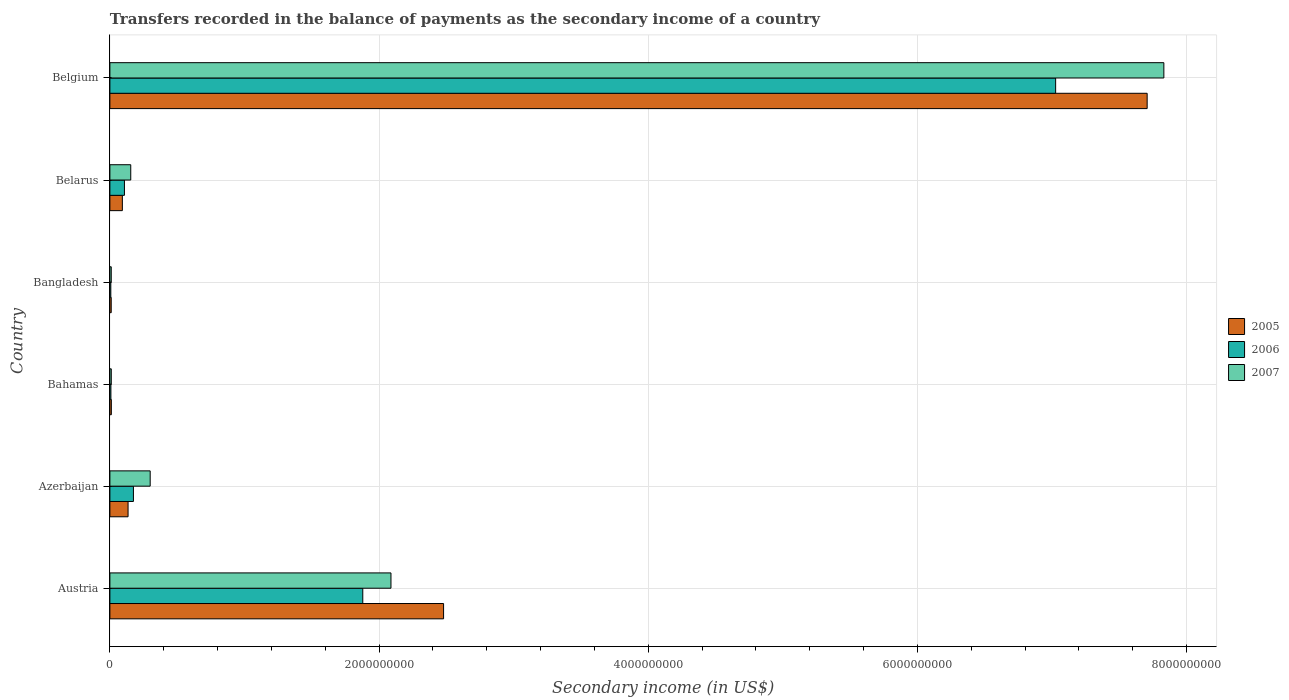How many different coloured bars are there?
Ensure brevity in your answer.  3. How many groups of bars are there?
Provide a succinct answer. 6. Are the number of bars per tick equal to the number of legend labels?
Your answer should be compact. Yes. Are the number of bars on each tick of the Y-axis equal?
Keep it short and to the point. Yes. How many bars are there on the 2nd tick from the top?
Ensure brevity in your answer.  3. How many bars are there on the 2nd tick from the bottom?
Your answer should be compact. 3. What is the label of the 3rd group of bars from the top?
Your answer should be very brief. Bangladesh. In how many cases, is the number of bars for a given country not equal to the number of legend labels?
Your answer should be very brief. 0. What is the secondary income of in 2007 in Bangladesh?
Keep it short and to the point. 1.01e+07. Across all countries, what is the maximum secondary income of in 2005?
Your answer should be very brief. 7.71e+09. Across all countries, what is the minimum secondary income of in 2007?
Your answer should be very brief. 1.01e+07. In which country was the secondary income of in 2005 minimum?
Give a very brief answer. Bangladesh. What is the total secondary income of in 2005 in the graph?
Your answer should be very brief. 1.04e+1. What is the difference between the secondary income of in 2006 in Austria and that in Belgium?
Make the answer very short. -5.15e+09. What is the difference between the secondary income of in 2006 in Bahamas and the secondary income of in 2005 in Azerbaijan?
Provide a short and direct response. -1.28e+08. What is the average secondary income of in 2005 per country?
Give a very brief answer. 1.74e+09. What is the difference between the secondary income of in 2005 and secondary income of in 2007 in Bangladesh?
Your answer should be very brief. -1.71e+05. What is the ratio of the secondary income of in 2007 in Austria to that in Azerbaijan?
Provide a succinct answer. 6.97. Is the secondary income of in 2005 in Azerbaijan less than that in Belarus?
Your answer should be very brief. No. What is the difference between the highest and the second highest secondary income of in 2006?
Offer a very short reply. 5.15e+09. What is the difference between the highest and the lowest secondary income of in 2007?
Your answer should be very brief. 7.82e+09. Is the sum of the secondary income of in 2007 in Azerbaijan and Bangladesh greater than the maximum secondary income of in 2006 across all countries?
Give a very brief answer. No. What does the 2nd bar from the bottom in Bahamas represents?
Offer a very short reply. 2006. Is it the case that in every country, the sum of the secondary income of in 2007 and secondary income of in 2005 is greater than the secondary income of in 2006?
Your answer should be compact. Yes. Are all the bars in the graph horizontal?
Ensure brevity in your answer.  Yes. What is the difference between two consecutive major ticks on the X-axis?
Offer a very short reply. 2.00e+09. Are the values on the major ticks of X-axis written in scientific E-notation?
Your response must be concise. No. Does the graph contain any zero values?
Offer a terse response. No. Does the graph contain grids?
Offer a terse response. Yes. Where does the legend appear in the graph?
Keep it short and to the point. Center right. How are the legend labels stacked?
Keep it short and to the point. Vertical. What is the title of the graph?
Your answer should be compact. Transfers recorded in the balance of payments as the secondary income of a country. What is the label or title of the X-axis?
Ensure brevity in your answer.  Secondary income (in US$). What is the label or title of the Y-axis?
Offer a terse response. Country. What is the Secondary income (in US$) of 2005 in Austria?
Offer a very short reply. 2.48e+09. What is the Secondary income (in US$) of 2006 in Austria?
Provide a succinct answer. 1.88e+09. What is the Secondary income (in US$) in 2007 in Austria?
Your response must be concise. 2.09e+09. What is the Secondary income (in US$) in 2005 in Azerbaijan?
Offer a very short reply. 1.35e+08. What is the Secondary income (in US$) of 2006 in Azerbaijan?
Provide a succinct answer. 1.75e+08. What is the Secondary income (in US$) in 2007 in Azerbaijan?
Give a very brief answer. 2.99e+08. What is the Secondary income (in US$) of 2005 in Bahamas?
Your answer should be compact. 1.08e+07. What is the Secondary income (in US$) of 2006 in Bahamas?
Give a very brief answer. 7.49e+06. What is the Secondary income (in US$) in 2007 in Bahamas?
Give a very brief answer. 1.03e+07. What is the Secondary income (in US$) in 2005 in Bangladesh?
Offer a very short reply. 9.91e+06. What is the Secondary income (in US$) in 2006 in Bangladesh?
Your answer should be compact. 6.82e+06. What is the Secondary income (in US$) in 2007 in Bangladesh?
Provide a short and direct response. 1.01e+07. What is the Secondary income (in US$) in 2005 in Belarus?
Give a very brief answer. 9.27e+07. What is the Secondary income (in US$) of 2006 in Belarus?
Provide a succinct answer. 1.08e+08. What is the Secondary income (in US$) in 2007 in Belarus?
Give a very brief answer. 1.55e+08. What is the Secondary income (in US$) in 2005 in Belgium?
Provide a succinct answer. 7.71e+09. What is the Secondary income (in US$) in 2006 in Belgium?
Ensure brevity in your answer.  7.03e+09. What is the Secondary income (in US$) in 2007 in Belgium?
Give a very brief answer. 7.83e+09. Across all countries, what is the maximum Secondary income (in US$) in 2005?
Give a very brief answer. 7.71e+09. Across all countries, what is the maximum Secondary income (in US$) of 2006?
Keep it short and to the point. 7.03e+09. Across all countries, what is the maximum Secondary income (in US$) of 2007?
Offer a very short reply. 7.83e+09. Across all countries, what is the minimum Secondary income (in US$) in 2005?
Offer a very short reply. 9.91e+06. Across all countries, what is the minimum Secondary income (in US$) of 2006?
Your response must be concise. 6.82e+06. Across all countries, what is the minimum Secondary income (in US$) in 2007?
Keep it short and to the point. 1.01e+07. What is the total Secondary income (in US$) of 2005 in the graph?
Your answer should be compact. 1.04e+1. What is the total Secondary income (in US$) in 2006 in the graph?
Your response must be concise. 9.20e+09. What is the total Secondary income (in US$) of 2007 in the graph?
Your answer should be very brief. 1.04e+1. What is the difference between the Secondary income (in US$) in 2005 in Austria and that in Azerbaijan?
Provide a short and direct response. 2.34e+09. What is the difference between the Secondary income (in US$) of 2006 in Austria and that in Azerbaijan?
Give a very brief answer. 1.70e+09. What is the difference between the Secondary income (in US$) in 2007 in Austria and that in Azerbaijan?
Give a very brief answer. 1.79e+09. What is the difference between the Secondary income (in US$) in 2005 in Austria and that in Bahamas?
Your answer should be very brief. 2.47e+09. What is the difference between the Secondary income (in US$) in 2006 in Austria and that in Bahamas?
Offer a terse response. 1.87e+09. What is the difference between the Secondary income (in US$) in 2007 in Austria and that in Bahamas?
Ensure brevity in your answer.  2.08e+09. What is the difference between the Secondary income (in US$) of 2005 in Austria and that in Bangladesh?
Offer a very short reply. 2.47e+09. What is the difference between the Secondary income (in US$) of 2006 in Austria and that in Bangladesh?
Offer a terse response. 1.87e+09. What is the difference between the Secondary income (in US$) in 2007 in Austria and that in Bangladesh?
Give a very brief answer. 2.08e+09. What is the difference between the Secondary income (in US$) of 2005 in Austria and that in Belarus?
Give a very brief answer. 2.39e+09. What is the difference between the Secondary income (in US$) in 2006 in Austria and that in Belarus?
Your answer should be compact. 1.77e+09. What is the difference between the Secondary income (in US$) of 2007 in Austria and that in Belarus?
Offer a very short reply. 1.93e+09. What is the difference between the Secondary income (in US$) in 2005 in Austria and that in Belgium?
Give a very brief answer. -5.23e+09. What is the difference between the Secondary income (in US$) in 2006 in Austria and that in Belgium?
Your answer should be compact. -5.15e+09. What is the difference between the Secondary income (in US$) of 2007 in Austria and that in Belgium?
Provide a succinct answer. -5.74e+09. What is the difference between the Secondary income (in US$) of 2005 in Azerbaijan and that in Bahamas?
Give a very brief answer. 1.24e+08. What is the difference between the Secondary income (in US$) in 2006 in Azerbaijan and that in Bahamas?
Make the answer very short. 1.67e+08. What is the difference between the Secondary income (in US$) in 2007 in Azerbaijan and that in Bahamas?
Your answer should be compact. 2.89e+08. What is the difference between the Secondary income (in US$) of 2005 in Azerbaijan and that in Bangladesh?
Offer a terse response. 1.25e+08. What is the difference between the Secondary income (in US$) in 2006 in Azerbaijan and that in Bangladesh?
Provide a short and direct response. 1.68e+08. What is the difference between the Secondary income (in US$) of 2007 in Azerbaijan and that in Bangladesh?
Provide a short and direct response. 2.89e+08. What is the difference between the Secondary income (in US$) of 2005 in Azerbaijan and that in Belarus?
Your answer should be very brief. 4.23e+07. What is the difference between the Secondary income (in US$) in 2006 in Azerbaijan and that in Belarus?
Give a very brief answer. 6.67e+07. What is the difference between the Secondary income (in US$) in 2007 in Azerbaijan and that in Belarus?
Give a very brief answer. 1.44e+08. What is the difference between the Secondary income (in US$) in 2005 in Azerbaijan and that in Belgium?
Offer a terse response. -7.57e+09. What is the difference between the Secondary income (in US$) of 2006 in Azerbaijan and that in Belgium?
Your answer should be compact. -6.85e+09. What is the difference between the Secondary income (in US$) of 2007 in Azerbaijan and that in Belgium?
Offer a terse response. -7.53e+09. What is the difference between the Secondary income (in US$) in 2005 in Bahamas and that in Bangladesh?
Your answer should be very brief. 8.77e+05. What is the difference between the Secondary income (in US$) in 2006 in Bahamas and that in Bangladesh?
Keep it short and to the point. 6.74e+05. What is the difference between the Secondary income (in US$) in 2007 in Bahamas and that in Bangladesh?
Your answer should be compact. 2.30e+05. What is the difference between the Secondary income (in US$) of 2005 in Bahamas and that in Belarus?
Offer a terse response. -8.19e+07. What is the difference between the Secondary income (in US$) in 2006 in Bahamas and that in Belarus?
Your answer should be compact. -1.01e+08. What is the difference between the Secondary income (in US$) of 2007 in Bahamas and that in Belarus?
Provide a short and direct response. -1.45e+08. What is the difference between the Secondary income (in US$) in 2005 in Bahamas and that in Belgium?
Provide a short and direct response. -7.70e+09. What is the difference between the Secondary income (in US$) in 2006 in Bahamas and that in Belgium?
Your answer should be compact. -7.02e+09. What is the difference between the Secondary income (in US$) in 2007 in Bahamas and that in Belgium?
Your answer should be very brief. -7.82e+09. What is the difference between the Secondary income (in US$) in 2005 in Bangladesh and that in Belarus?
Offer a very short reply. -8.28e+07. What is the difference between the Secondary income (in US$) of 2006 in Bangladesh and that in Belarus?
Provide a short and direct response. -1.01e+08. What is the difference between the Secondary income (in US$) in 2007 in Bangladesh and that in Belarus?
Give a very brief answer. -1.45e+08. What is the difference between the Secondary income (in US$) of 2005 in Bangladesh and that in Belgium?
Provide a short and direct response. -7.70e+09. What is the difference between the Secondary income (in US$) of 2006 in Bangladesh and that in Belgium?
Offer a very short reply. -7.02e+09. What is the difference between the Secondary income (in US$) in 2007 in Bangladesh and that in Belgium?
Make the answer very short. -7.82e+09. What is the difference between the Secondary income (in US$) of 2005 in Belarus and that in Belgium?
Make the answer very short. -7.61e+09. What is the difference between the Secondary income (in US$) in 2006 in Belarus and that in Belgium?
Offer a terse response. -6.92e+09. What is the difference between the Secondary income (in US$) in 2007 in Belarus and that in Belgium?
Make the answer very short. -7.68e+09. What is the difference between the Secondary income (in US$) in 2005 in Austria and the Secondary income (in US$) in 2006 in Azerbaijan?
Your answer should be compact. 2.30e+09. What is the difference between the Secondary income (in US$) of 2005 in Austria and the Secondary income (in US$) of 2007 in Azerbaijan?
Your response must be concise. 2.18e+09. What is the difference between the Secondary income (in US$) of 2006 in Austria and the Secondary income (in US$) of 2007 in Azerbaijan?
Offer a very short reply. 1.58e+09. What is the difference between the Secondary income (in US$) of 2005 in Austria and the Secondary income (in US$) of 2006 in Bahamas?
Offer a terse response. 2.47e+09. What is the difference between the Secondary income (in US$) in 2005 in Austria and the Secondary income (in US$) in 2007 in Bahamas?
Offer a terse response. 2.47e+09. What is the difference between the Secondary income (in US$) in 2006 in Austria and the Secondary income (in US$) in 2007 in Bahamas?
Give a very brief answer. 1.87e+09. What is the difference between the Secondary income (in US$) of 2005 in Austria and the Secondary income (in US$) of 2006 in Bangladesh?
Offer a terse response. 2.47e+09. What is the difference between the Secondary income (in US$) in 2005 in Austria and the Secondary income (in US$) in 2007 in Bangladesh?
Make the answer very short. 2.47e+09. What is the difference between the Secondary income (in US$) of 2006 in Austria and the Secondary income (in US$) of 2007 in Bangladesh?
Offer a terse response. 1.87e+09. What is the difference between the Secondary income (in US$) of 2005 in Austria and the Secondary income (in US$) of 2006 in Belarus?
Your answer should be very brief. 2.37e+09. What is the difference between the Secondary income (in US$) of 2005 in Austria and the Secondary income (in US$) of 2007 in Belarus?
Keep it short and to the point. 2.32e+09. What is the difference between the Secondary income (in US$) in 2006 in Austria and the Secondary income (in US$) in 2007 in Belarus?
Keep it short and to the point. 1.72e+09. What is the difference between the Secondary income (in US$) of 2005 in Austria and the Secondary income (in US$) of 2006 in Belgium?
Your answer should be compact. -4.55e+09. What is the difference between the Secondary income (in US$) of 2005 in Austria and the Secondary income (in US$) of 2007 in Belgium?
Your response must be concise. -5.35e+09. What is the difference between the Secondary income (in US$) in 2006 in Austria and the Secondary income (in US$) in 2007 in Belgium?
Offer a terse response. -5.95e+09. What is the difference between the Secondary income (in US$) of 2005 in Azerbaijan and the Secondary income (in US$) of 2006 in Bahamas?
Provide a succinct answer. 1.28e+08. What is the difference between the Secondary income (in US$) of 2005 in Azerbaijan and the Secondary income (in US$) of 2007 in Bahamas?
Keep it short and to the point. 1.25e+08. What is the difference between the Secondary income (in US$) in 2006 in Azerbaijan and the Secondary income (in US$) in 2007 in Bahamas?
Make the answer very short. 1.64e+08. What is the difference between the Secondary income (in US$) in 2005 in Azerbaijan and the Secondary income (in US$) in 2006 in Bangladesh?
Give a very brief answer. 1.28e+08. What is the difference between the Secondary income (in US$) in 2005 in Azerbaijan and the Secondary income (in US$) in 2007 in Bangladesh?
Ensure brevity in your answer.  1.25e+08. What is the difference between the Secondary income (in US$) of 2006 in Azerbaijan and the Secondary income (in US$) of 2007 in Bangladesh?
Your answer should be compact. 1.65e+08. What is the difference between the Secondary income (in US$) in 2005 in Azerbaijan and the Secondary income (in US$) in 2006 in Belarus?
Keep it short and to the point. 2.69e+07. What is the difference between the Secondary income (in US$) of 2005 in Azerbaijan and the Secondary income (in US$) of 2007 in Belarus?
Provide a short and direct response. -2.00e+07. What is the difference between the Secondary income (in US$) in 2006 in Azerbaijan and the Secondary income (in US$) in 2007 in Belarus?
Give a very brief answer. 1.98e+07. What is the difference between the Secondary income (in US$) of 2005 in Azerbaijan and the Secondary income (in US$) of 2006 in Belgium?
Offer a terse response. -6.89e+09. What is the difference between the Secondary income (in US$) in 2005 in Azerbaijan and the Secondary income (in US$) in 2007 in Belgium?
Ensure brevity in your answer.  -7.70e+09. What is the difference between the Secondary income (in US$) in 2006 in Azerbaijan and the Secondary income (in US$) in 2007 in Belgium?
Your answer should be compact. -7.66e+09. What is the difference between the Secondary income (in US$) of 2005 in Bahamas and the Secondary income (in US$) of 2006 in Bangladesh?
Give a very brief answer. 3.97e+06. What is the difference between the Secondary income (in US$) in 2005 in Bahamas and the Secondary income (in US$) in 2007 in Bangladesh?
Keep it short and to the point. 7.06e+05. What is the difference between the Secondary income (in US$) in 2006 in Bahamas and the Secondary income (in US$) in 2007 in Bangladesh?
Offer a terse response. -2.59e+06. What is the difference between the Secondary income (in US$) of 2005 in Bahamas and the Secondary income (in US$) of 2006 in Belarus?
Keep it short and to the point. -9.73e+07. What is the difference between the Secondary income (in US$) of 2005 in Bahamas and the Secondary income (in US$) of 2007 in Belarus?
Provide a short and direct response. -1.44e+08. What is the difference between the Secondary income (in US$) in 2006 in Bahamas and the Secondary income (in US$) in 2007 in Belarus?
Ensure brevity in your answer.  -1.48e+08. What is the difference between the Secondary income (in US$) of 2005 in Bahamas and the Secondary income (in US$) of 2006 in Belgium?
Keep it short and to the point. -7.02e+09. What is the difference between the Secondary income (in US$) of 2005 in Bahamas and the Secondary income (in US$) of 2007 in Belgium?
Ensure brevity in your answer.  -7.82e+09. What is the difference between the Secondary income (in US$) in 2006 in Bahamas and the Secondary income (in US$) in 2007 in Belgium?
Your answer should be very brief. -7.82e+09. What is the difference between the Secondary income (in US$) in 2005 in Bangladesh and the Secondary income (in US$) in 2006 in Belarus?
Your response must be concise. -9.82e+07. What is the difference between the Secondary income (in US$) in 2005 in Bangladesh and the Secondary income (in US$) in 2007 in Belarus?
Your response must be concise. -1.45e+08. What is the difference between the Secondary income (in US$) of 2006 in Bangladesh and the Secondary income (in US$) of 2007 in Belarus?
Ensure brevity in your answer.  -1.48e+08. What is the difference between the Secondary income (in US$) of 2005 in Bangladesh and the Secondary income (in US$) of 2006 in Belgium?
Make the answer very short. -7.02e+09. What is the difference between the Secondary income (in US$) of 2005 in Bangladesh and the Secondary income (in US$) of 2007 in Belgium?
Your response must be concise. -7.82e+09. What is the difference between the Secondary income (in US$) in 2006 in Bangladesh and the Secondary income (in US$) in 2007 in Belgium?
Ensure brevity in your answer.  -7.82e+09. What is the difference between the Secondary income (in US$) in 2005 in Belarus and the Secondary income (in US$) in 2006 in Belgium?
Give a very brief answer. -6.93e+09. What is the difference between the Secondary income (in US$) of 2005 in Belarus and the Secondary income (in US$) of 2007 in Belgium?
Your answer should be very brief. -7.74e+09. What is the difference between the Secondary income (in US$) of 2006 in Belarus and the Secondary income (in US$) of 2007 in Belgium?
Your response must be concise. -7.72e+09. What is the average Secondary income (in US$) of 2005 per country?
Provide a short and direct response. 1.74e+09. What is the average Secondary income (in US$) of 2006 per country?
Provide a short and direct response. 1.53e+09. What is the average Secondary income (in US$) in 2007 per country?
Ensure brevity in your answer.  1.73e+09. What is the difference between the Secondary income (in US$) in 2005 and Secondary income (in US$) in 2006 in Austria?
Make the answer very short. 6.00e+08. What is the difference between the Secondary income (in US$) of 2005 and Secondary income (in US$) of 2007 in Austria?
Offer a very short reply. 3.91e+08. What is the difference between the Secondary income (in US$) in 2006 and Secondary income (in US$) in 2007 in Austria?
Offer a very short reply. -2.09e+08. What is the difference between the Secondary income (in US$) of 2005 and Secondary income (in US$) of 2006 in Azerbaijan?
Your response must be concise. -3.98e+07. What is the difference between the Secondary income (in US$) in 2005 and Secondary income (in US$) in 2007 in Azerbaijan?
Give a very brief answer. -1.64e+08. What is the difference between the Secondary income (in US$) in 2006 and Secondary income (in US$) in 2007 in Azerbaijan?
Your answer should be very brief. -1.25e+08. What is the difference between the Secondary income (in US$) of 2005 and Secondary income (in US$) of 2006 in Bahamas?
Offer a terse response. 3.30e+06. What is the difference between the Secondary income (in US$) of 2005 and Secondary income (in US$) of 2007 in Bahamas?
Give a very brief answer. 4.76e+05. What is the difference between the Secondary income (in US$) of 2006 and Secondary income (in US$) of 2007 in Bahamas?
Provide a succinct answer. -2.82e+06. What is the difference between the Secondary income (in US$) in 2005 and Secondary income (in US$) in 2006 in Bangladesh?
Keep it short and to the point. 3.09e+06. What is the difference between the Secondary income (in US$) of 2005 and Secondary income (in US$) of 2007 in Bangladesh?
Give a very brief answer. -1.71e+05. What is the difference between the Secondary income (in US$) of 2006 and Secondary income (in US$) of 2007 in Bangladesh?
Provide a short and direct response. -3.26e+06. What is the difference between the Secondary income (in US$) of 2005 and Secondary income (in US$) of 2006 in Belarus?
Give a very brief answer. -1.54e+07. What is the difference between the Secondary income (in US$) of 2005 and Secondary income (in US$) of 2007 in Belarus?
Your answer should be compact. -6.23e+07. What is the difference between the Secondary income (in US$) of 2006 and Secondary income (in US$) of 2007 in Belarus?
Offer a terse response. -4.69e+07. What is the difference between the Secondary income (in US$) of 2005 and Secondary income (in US$) of 2006 in Belgium?
Offer a very short reply. 6.80e+08. What is the difference between the Secondary income (in US$) of 2005 and Secondary income (in US$) of 2007 in Belgium?
Your answer should be very brief. -1.24e+08. What is the difference between the Secondary income (in US$) of 2006 and Secondary income (in US$) of 2007 in Belgium?
Provide a short and direct response. -8.04e+08. What is the ratio of the Secondary income (in US$) in 2005 in Austria to that in Azerbaijan?
Provide a succinct answer. 18.36. What is the ratio of the Secondary income (in US$) in 2006 in Austria to that in Azerbaijan?
Make the answer very short. 10.75. What is the ratio of the Secondary income (in US$) of 2007 in Austria to that in Azerbaijan?
Your answer should be compact. 6.97. What is the ratio of the Secondary income (in US$) in 2005 in Austria to that in Bahamas?
Offer a terse response. 229.87. What is the ratio of the Secondary income (in US$) of 2006 in Austria to that in Bahamas?
Offer a very short reply. 250.88. What is the ratio of the Secondary income (in US$) of 2007 in Austria to that in Bahamas?
Offer a very short reply. 202.57. What is the ratio of the Secondary income (in US$) in 2005 in Austria to that in Bangladesh?
Ensure brevity in your answer.  250.21. What is the ratio of the Secondary income (in US$) in 2006 in Austria to that in Bangladesh?
Your response must be concise. 275.69. What is the ratio of the Secondary income (in US$) in 2007 in Austria to that in Bangladesh?
Offer a very short reply. 207.18. What is the ratio of the Secondary income (in US$) of 2005 in Austria to that in Belarus?
Your response must be concise. 26.75. What is the ratio of the Secondary income (in US$) of 2006 in Austria to that in Belarus?
Keep it short and to the point. 17.38. What is the ratio of the Secondary income (in US$) in 2007 in Austria to that in Belarus?
Give a very brief answer. 13.47. What is the ratio of the Secondary income (in US$) in 2005 in Austria to that in Belgium?
Offer a terse response. 0.32. What is the ratio of the Secondary income (in US$) in 2006 in Austria to that in Belgium?
Make the answer very short. 0.27. What is the ratio of the Secondary income (in US$) in 2007 in Austria to that in Belgium?
Provide a succinct answer. 0.27. What is the ratio of the Secondary income (in US$) in 2005 in Azerbaijan to that in Bahamas?
Ensure brevity in your answer.  12.52. What is the ratio of the Secondary income (in US$) of 2006 in Azerbaijan to that in Bahamas?
Provide a succinct answer. 23.34. What is the ratio of the Secondary income (in US$) of 2007 in Azerbaijan to that in Bahamas?
Offer a very short reply. 29.04. What is the ratio of the Secondary income (in US$) in 2005 in Azerbaijan to that in Bangladesh?
Offer a terse response. 13.63. What is the ratio of the Secondary income (in US$) in 2006 in Azerbaijan to that in Bangladesh?
Make the answer very short. 25.65. What is the ratio of the Secondary income (in US$) in 2007 in Azerbaijan to that in Bangladesh?
Provide a succinct answer. 29.7. What is the ratio of the Secondary income (in US$) of 2005 in Azerbaijan to that in Belarus?
Give a very brief answer. 1.46. What is the ratio of the Secondary income (in US$) in 2006 in Azerbaijan to that in Belarus?
Keep it short and to the point. 1.62. What is the ratio of the Secondary income (in US$) of 2007 in Azerbaijan to that in Belarus?
Provide a short and direct response. 1.93. What is the ratio of the Secondary income (in US$) in 2005 in Azerbaijan to that in Belgium?
Provide a succinct answer. 0.02. What is the ratio of the Secondary income (in US$) of 2006 in Azerbaijan to that in Belgium?
Offer a terse response. 0.02. What is the ratio of the Secondary income (in US$) in 2007 in Azerbaijan to that in Belgium?
Your response must be concise. 0.04. What is the ratio of the Secondary income (in US$) of 2005 in Bahamas to that in Bangladesh?
Offer a terse response. 1.09. What is the ratio of the Secondary income (in US$) of 2006 in Bahamas to that in Bangladesh?
Your answer should be compact. 1.1. What is the ratio of the Secondary income (in US$) in 2007 in Bahamas to that in Bangladesh?
Offer a very short reply. 1.02. What is the ratio of the Secondary income (in US$) in 2005 in Bahamas to that in Belarus?
Your answer should be very brief. 0.12. What is the ratio of the Secondary income (in US$) of 2006 in Bahamas to that in Belarus?
Offer a terse response. 0.07. What is the ratio of the Secondary income (in US$) in 2007 in Bahamas to that in Belarus?
Keep it short and to the point. 0.07. What is the ratio of the Secondary income (in US$) of 2005 in Bahamas to that in Belgium?
Your answer should be very brief. 0. What is the ratio of the Secondary income (in US$) of 2006 in Bahamas to that in Belgium?
Your answer should be compact. 0. What is the ratio of the Secondary income (in US$) of 2007 in Bahamas to that in Belgium?
Give a very brief answer. 0. What is the ratio of the Secondary income (in US$) of 2005 in Bangladesh to that in Belarus?
Your answer should be compact. 0.11. What is the ratio of the Secondary income (in US$) of 2006 in Bangladesh to that in Belarus?
Your answer should be compact. 0.06. What is the ratio of the Secondary income (in US$) in 2007 in Bangladesh to that in Belarus?
Make the answer very short. 0.07. What is the ratio of the Secondary income (in US$) in 2005 in Bangladesh to that in Belgium?
Make the answer very short. 0. What is the ratio of the Secondary income (in US$) in 2007 in Bangladesh to that in Belgium?
Offer a terse response. 0. What is the ratio of the Secondary income (in US$) in 2005 in Belarus to that in Belgium?
Your answer should be very brief. 0.01. What is the ratio of the Secondary income (in US$) in 2006 in Belarus to that in Belgium?
Offer a terse response. 0.02. What is the ratio of the Secondary income (in US$) in 2007 in Belarus to that in Belgium?
Keep it short and to the point. 0.02. What is the difference between the highest and the second highest Secondary income (in US$) in 2005?
Your answer should be compact. 5.23e+09. What is the difference between the highest and the second highest Secondary income (in US$) in 2006?
Your response must be concise. 5.15e+09. What is the difference between the highest and the second highest Secondary income (in US$) of 2007?
Your answer should be compact. 5.74e+09. What is the difference between the highest and the lowest Secondary income (in US$) of 2005?
Give a very brief answer. 7.70e+09. What is the difference between the highest and the lowest Secondary income (in US$) of 2006?
Offer a terse response. 7.02e+09. What is the difference between the highest and the lowest Secondary income (in US$) of 2007?
Offer a terse response. 7.82e+09. 